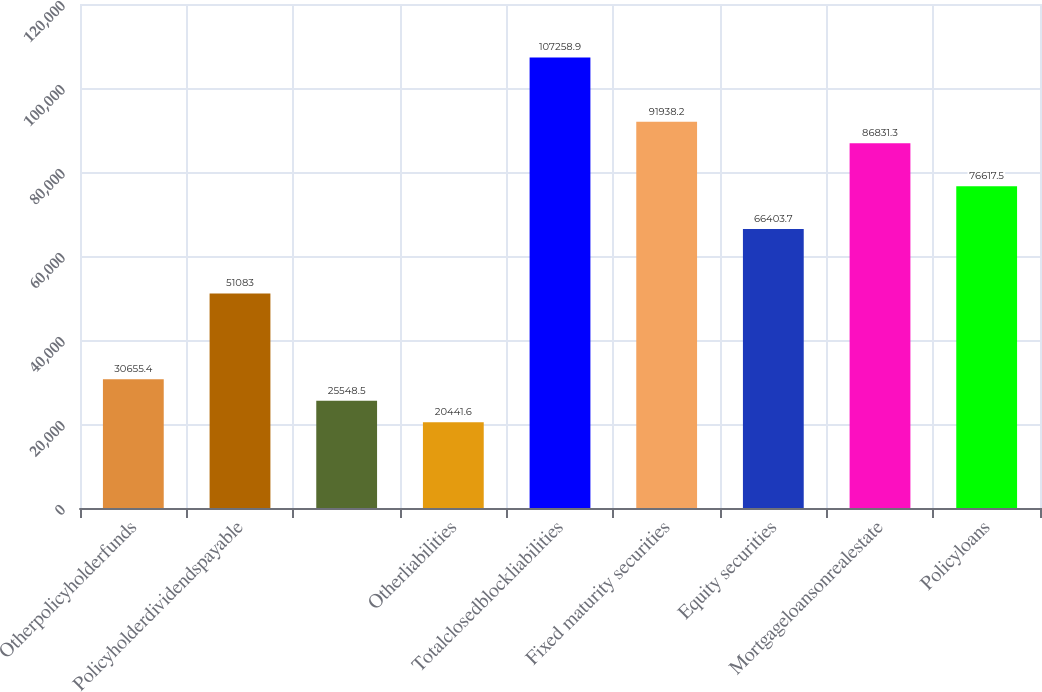Convert chart. <chart><loc_0><loc_0><loc_500><loc_500><bar_chart><fcel>Otherpolicyholderfunds<fcel>Policyholderdividendspayable<fcel>Unnamed: 2<fcel>Otherliabilities<fcel>Totalclosedblockliabilities<fcel>Fixed maturity securities<fcel>Equity securities<fcel>Mortgageloansonrealestate<fcel>Policyloans<nl><fcel>30655.4<fcel>51083<fcel>25548.5<fcel>20441.6<fcel>107259<fcel>91938.2<fcel>66403.7<fcel>86831.3<fcel>76617.5<nl></chart> 